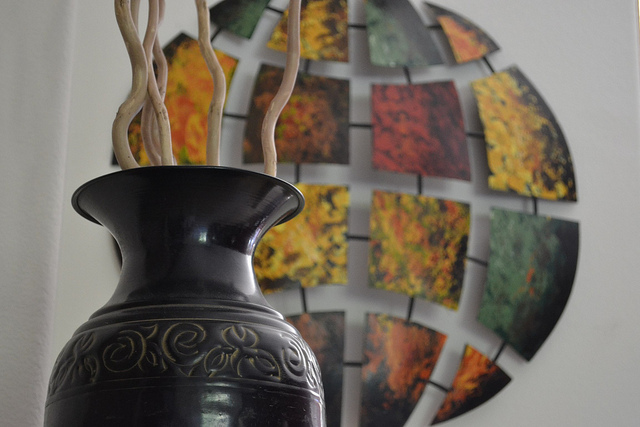<image>Who gave this vase? It is unknown who gave this vase. It can be a friend, family member, or even Santa. Who gave this vase? I don't know who gave this vase. It could be either no one, a friend, a store, family, grandmother, Santa, or mom. 